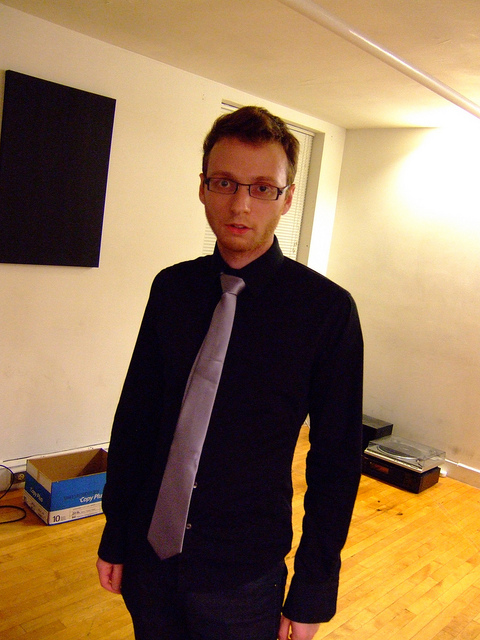The walls are quite bare. What are some ways to add personality to this space? Adding personality to bare walls can be achieved through various means. Hanging artwork or framed pictures can reflect personal taste, while shelves with books or collectibles can inject a sense of character into the space. Additionally, using wall decals or a fresh coat of vibrant paint can also make the area feel more personal and lively. 